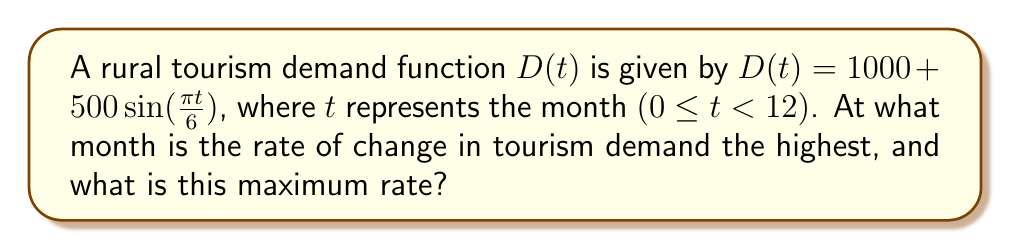Solve this math problem. To solve this problem, we need to follow these steps:

1) First, we need to find the derivative of the demand function $D(t)$ with respect to $t$:
   $$D'(t) = 500 \cdot \frac{\pi}{6} \cos(\frac{\pi t}{6})$$

2) The rate of change is highest when $D'(t)$ is at its maximum value. To find this, we need to determine when $\cos(\frac{\pi t}{6})$ equals 1, its maximum value.

3) $\cos(\frac{\pi t}{6}) = 1$ when $\frac{\pi t}{6} = 2\pi n$, where $n$ is an integer. Solving for $t$:
   $$t = 12n$$

4) Given that $0 \leq t < 12$, the only solution is when $n = 0$, so $t = 0$.

5) This corresponds to the beginning of the year, or January (month 0 in the given scale).

6) To find the maximum rate, we substitute $t = 0$ into $D'(t)$:
   $$D'(0) = 500 \cdot \frac{\pi}{6} \cos(0) = 500 \cdot \frac{\pi}{6} \approx 261.8$$

Therefore, the rate of change in tourism demand is highest in January (t = 0), and the maximum rate is approximately 261.8 tourists per month.
Answer: January; 261.8 tourists/month 